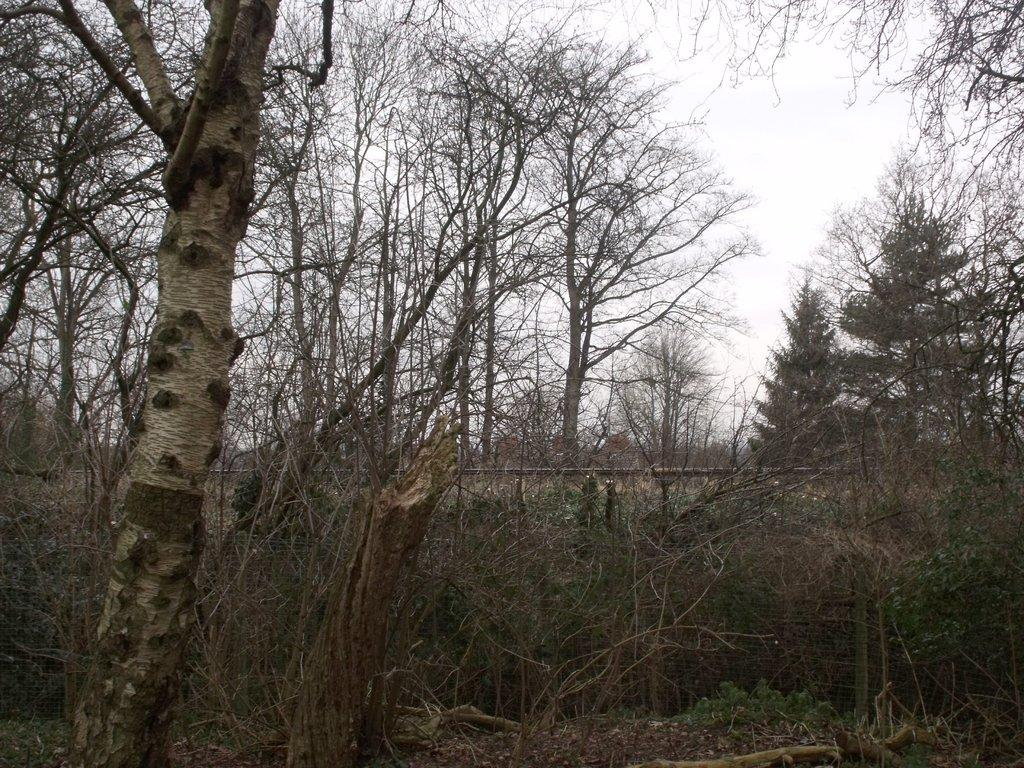What type of vegetation can be seen in the image? There are trees in the image. What is the man-made structure visible in the image? There is a wall in the image. What is visible in the background of the image? The sky is visible in the background of the image. What color is the hair on the trees in the image? There is no hair present on the trees in the image, as trees do not have hair. What type of base is supporting the wall in the image? The image does not provide information about the base supporting the wall, so it cannot be determined from the image. 